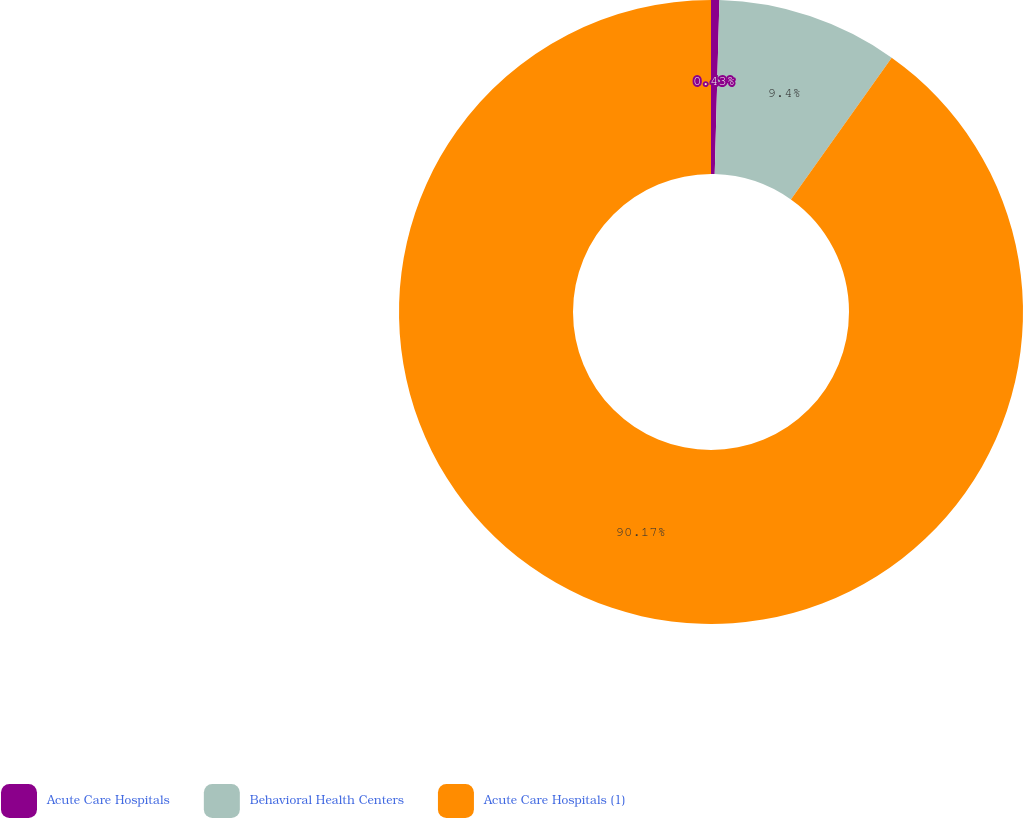<chart> <loc_0><loc_0><loc_500><loc_500><pie_chart><fcel>Acute Care Hospitals<fcel>Behavioral Health Centers<fcel>Acute Care Hospitals (1)<nl><fcel>0.43%<fcel>9.4%<fcel>90.16%<nl></chart> 